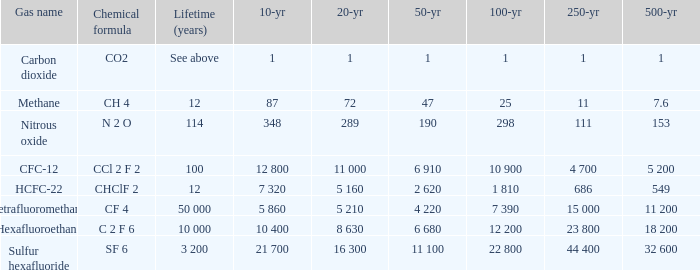What is the 20 year for Nitrous Oxide? 289.0. 